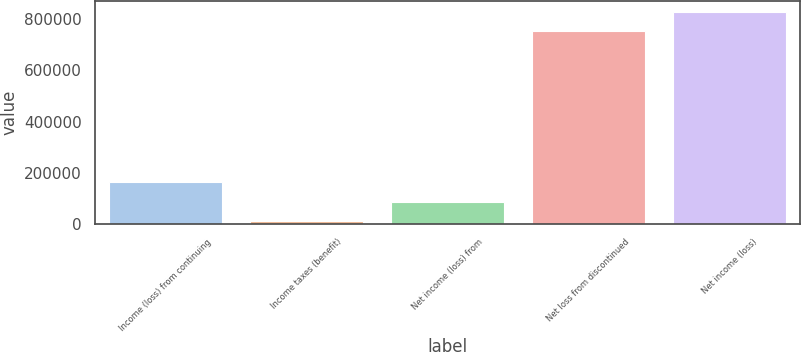<chart> <loc_0><loc_0><loc_500><loc_500><bar_chart><fcel>Income (loss) from continuing<fcel>Income taxes (benefit)<fcel>Net income (loss) from<fcel>Net loss from discontinued<fcel>Net income (loss)<nl><fcel>164799<fcel>10351<fcel>87574.9<fcel>752386<fcel>829610<nl></chart> 